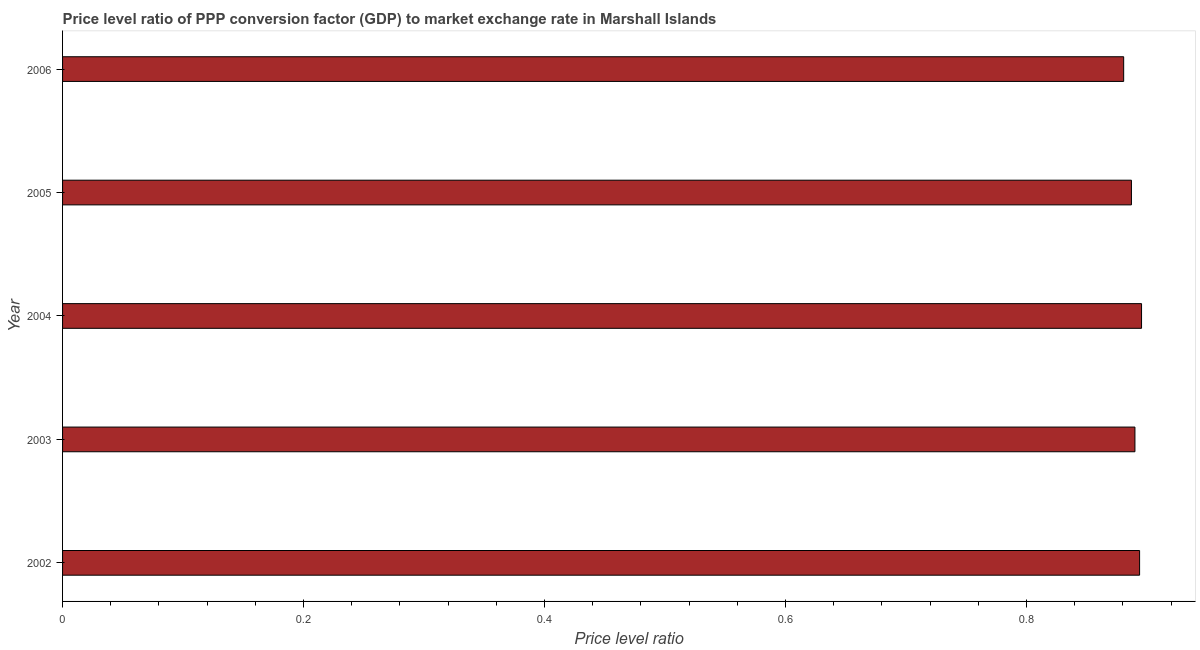Does the graph contain grids?
Your answer should be very brief. No. What is the title of the graph?
Offer a very short reply. Price level ratio of PPP conversion factor (GDP) to market exchange rate in Marshall Islands. What is the label or title of the X-axis?
Provide a succinct answer. Price level ratio. What is the label or title of the Y-axis?
Offer a very short reply. Year. What is the price level ratio in 2005?
Provide a succinct answer. 0.89. Across all years, what is the maximum price level ratio?
Make the answer very short. 0.9. Across all years, what is the minimum price level ratio?
Offer a very short reply. 0.88. In which year was the price level ratio maximum?
Make the answer very short. 2004. In which year was the price level ratio minimum?
Offer a terse response. 2006. What is the sum of the price level ratio?
Keep it short and to the point. 4.45. What is the difference between the price level ratio in 2002 and 2003?
Keep it short and to the point. 0. What is the average price level ratio per year?
Provide a short and direct response. 0.89. What is the median price level ratio?
Ensure brevity in your answer.  0.89. In how many years, is the price level ratio greater than 0.76 ?
Offer a terse response. 5. Do a majority of the years between 2006 and 2005 (inclusive) have price level ratio greater than 0.44 ?
Your answer should be compact. No. What is the ratio of the price level ratio in 2002 to that in 2004?
Offer a terse response. 1. Is the difference between the price level ratio in 2002 and 2004 greater than the difference between any two years?
Ensure brevity in your answer.  No. What is the difference between the highest and the second highest price level ratio?
Ensure brevity in your answer.  0. Is the sum of the price level ratio in 2005 and 2006 greater than the maximum price level ratio across all years?
Provide a short and direct response. Yes. What is the difference between the highest and the lowest price level ratio?
Ensure brevity in your answer.  0.01. How many bars are there?
Make the answer very short. 5. What is the difference between two consecutive major ticks on the X-axis?
Your answer should be compact. 0.2. What is the Price level ratio in 2002?
Make the answer very short. 0.89. What is the Price level ratio of 2003?
Your answer should be compact. 0.89. What is the Price level ratio of 2004?
Your response must be concise. 0.9. What is the Price level ratio of 2005?
Ensure brevity in your answer.  0.89. What is the Price level ratio in 2006?
Your answer should be very brief. 0.88. What is the difference between the Price level ratio in 2002 and 2003?
Provide a short and direct response. 0. What is the difference between the Price level ratio in 2002 and 2004?
Provide a succinct answer. -0. What is the difference between the Price level ratio in 2002 and 2005?
Make the answer very short. 0.01. What is the difference between the Price level ratio in 2002 and 2006?
Offer a terse response. 0.01. What is the difference between the Price level ratio in 2003 and 2004?
Your answer should be very brief. -0.01. What is the difference between the Price level ratio in 2003 and 2005?
Give a very brief answer. 0. What is the difference between the Price level ratio in 2003 and 2006?
Provide a succinct answer. 0.01. What is the difference between the Price level ratio in 2004 and 2005?
Your response must be concise. 0.01. What is the difference between the Price level ratio in 2004 and 2006?
Your response must be concise. 0.01. What is the difference between the Price level ratio in 2005 and 2006?
Your answer should be very brief. 0.01. What is the ratio of the Price level ratio in 2002 to that in 2003?
Provide a succinct answer. 1. What is the ratio of the Price level ratio in 2002 to that in 2004?
Your answer should be compact. 1. What is the ratio of the Price level ratio in 2002 to that in 2006?
Your answer should be very brief. 1.01. What is the ratio of the Price level ratio in 2005 to that in 2006?
Ensure brevity in your answer.  1.01. 